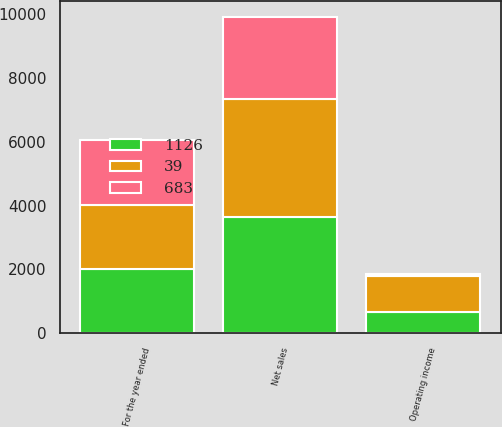Convert chart. <chart><loc_0><loc_0><loc_500><loc_500><stacked_bar_chart><ecel><fcel>For the year ended<fcel>Net sales<fcel>Operating income<nl><fcel>683<fcel>2016<fcel>2569<fcel>39<nl><fcel>39<fcel>2015<fcel>3692<fcel>1126<nl><fcel>1126<fcel>2014<fcel>3627<fcel>683<nl></chart> 